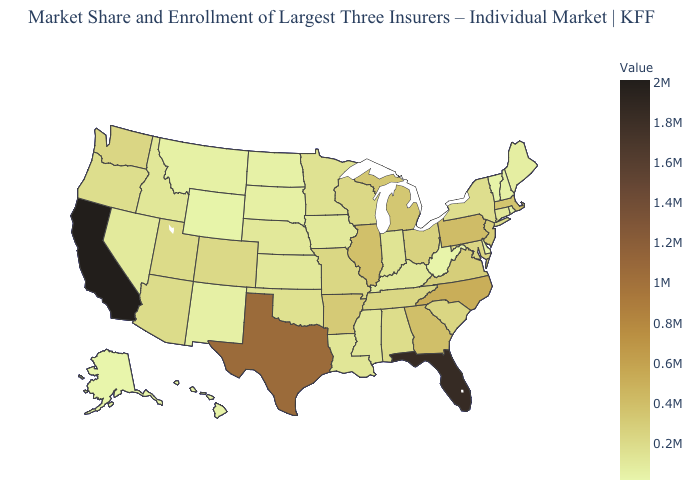Does Maine have the highest value in the USA?
Answer briefly. No. Among the states that border Idaho , which have the lowest value?
Keep it brief. Wyoming. Among the states that border Maryland , which have the lowest value?
Quick response, please. West Virginia. 